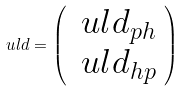<formula> <loc_0><loc_0><loc_500><loc_500>\ u l { d } = \left ( \begin{array} { c } \ u l { d } _ { p h } \\ \ u l { d } _ { h p } \end{array} \right )</formula> 